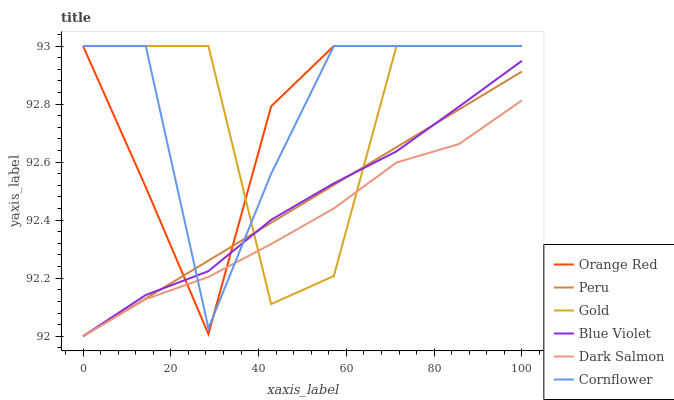Does Dark Salmon have the minimum area under the curve?
Answer yes or no. Yes. Does Cornflower have the maximum area under the curve?
Answer yes or no. Yes. Does Gold have the minimum area under the curve?
Answer yes or no. No. Does Gold have the maximum area under the curve?
Answer yes or no. No. Is Peru the smoothest?
Answer yes or no. Yes. Is Gold the roughest?
Answer yes or no. Yes. Is Dark Salmon the smoothest?
Answer yes or no. No. Is Dark Salmon the roughest?
Answer yes or no. No. Does Dark Salmon have the lowest value?
Answer yes or no. Yes. Does Gold have the lowest value?
Answer yes or no. No. Does Orange Red have the highest value?
Answer yes or no. Yes. Does Dark Salmon have the highest value?
Answer yes or no. No. Does Gold intersect Blue Violet?
Answer yes or no. Yes. Is Gold less than Blue Violet?
Answer yes or no. No. Is Gold greater than Blue Violet?
Answer yes or no. No. 